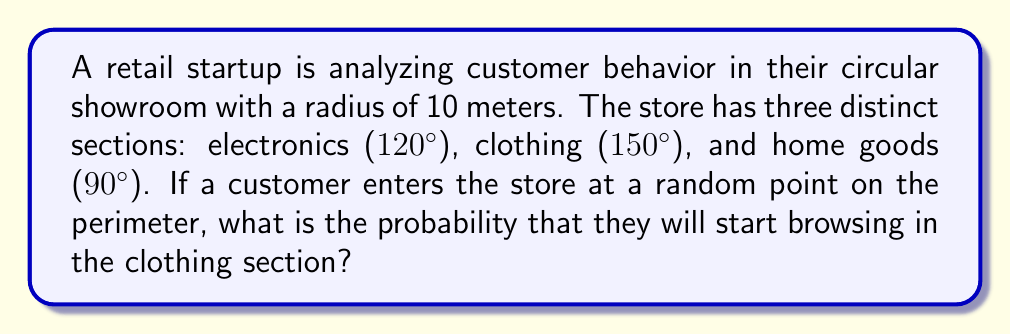Teach me how to tackle this problem. To solve this problem, we need to use geometric probability. In a circular space, the probability of an event occurring is proportional to the central angle that subtends the area where the event can occur.

Step 1: Calculate the total angle of the circle.
Total angle = 360°

Step 2: Identify the angle of the clothing section.
Clothing section angle = 150°

Step 3: Calculate the probability using the ratio of the clothing section angle to the total angle.

$$P(\text{clothing}) = \frac{\text{Clothing section angle}}{\text{Total angle}} = \frac{150°}{360°}$$

Step 4: Simplify the fraction.

$$P(\text{clothing}) = \frac{150}{360} = \frac{5}{12} \approx 0.4167$$

Therefore, the probability that a customer will start browsing in the clothing section is $\frac{5}{12}$ or approximately 41.67%.

This analysis can help the startup understand customer entry patterns and potentially optimize product placement or marketing strategies near the store entrance.
Answer: $\frac{5}{12}$ 